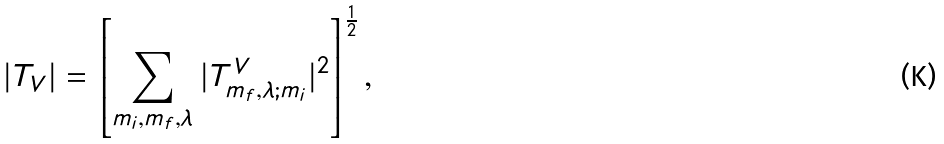<formula> <loc_0><loc_0><loc_500><loc_500>| T _ { V } | = \left [ { \sum _ { m _ { i } , m _ { f } , \lambda } | T ^ { V } _ { m _ { f } , \lambda ; m _ { i } } | ^ { 2 } } \right ] ^ { \frac { 1 } { 2 } } ,</formula> 